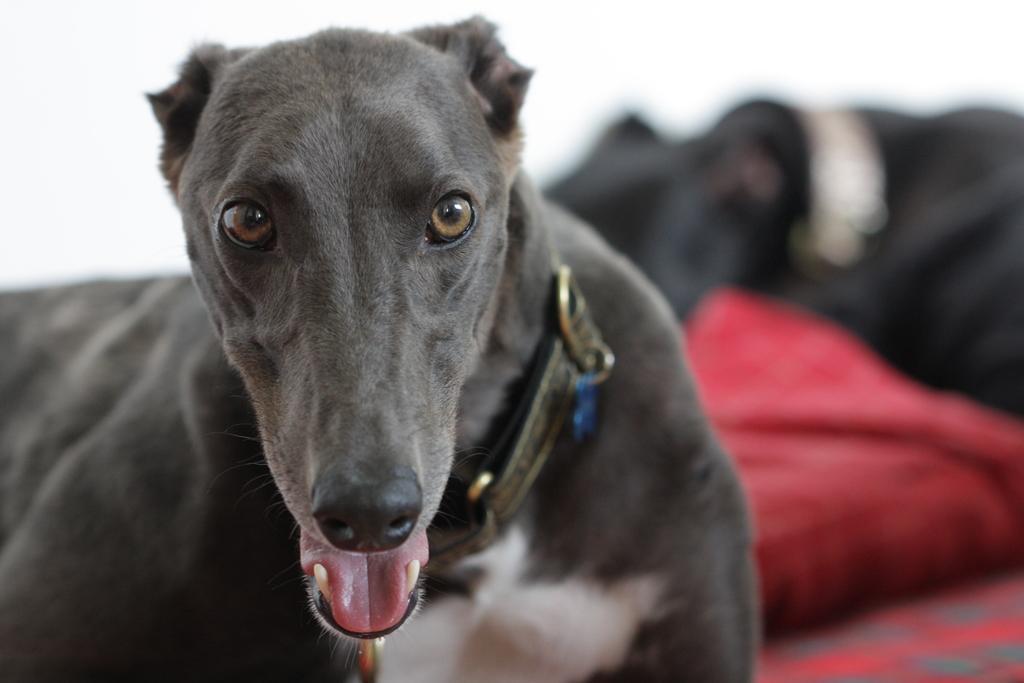Describe this image in one or two sentences. In this image, we can see a dog wearing a belt. The background of the image is white. On the right side of the image, we can see the blur view, red, black and white colors. 